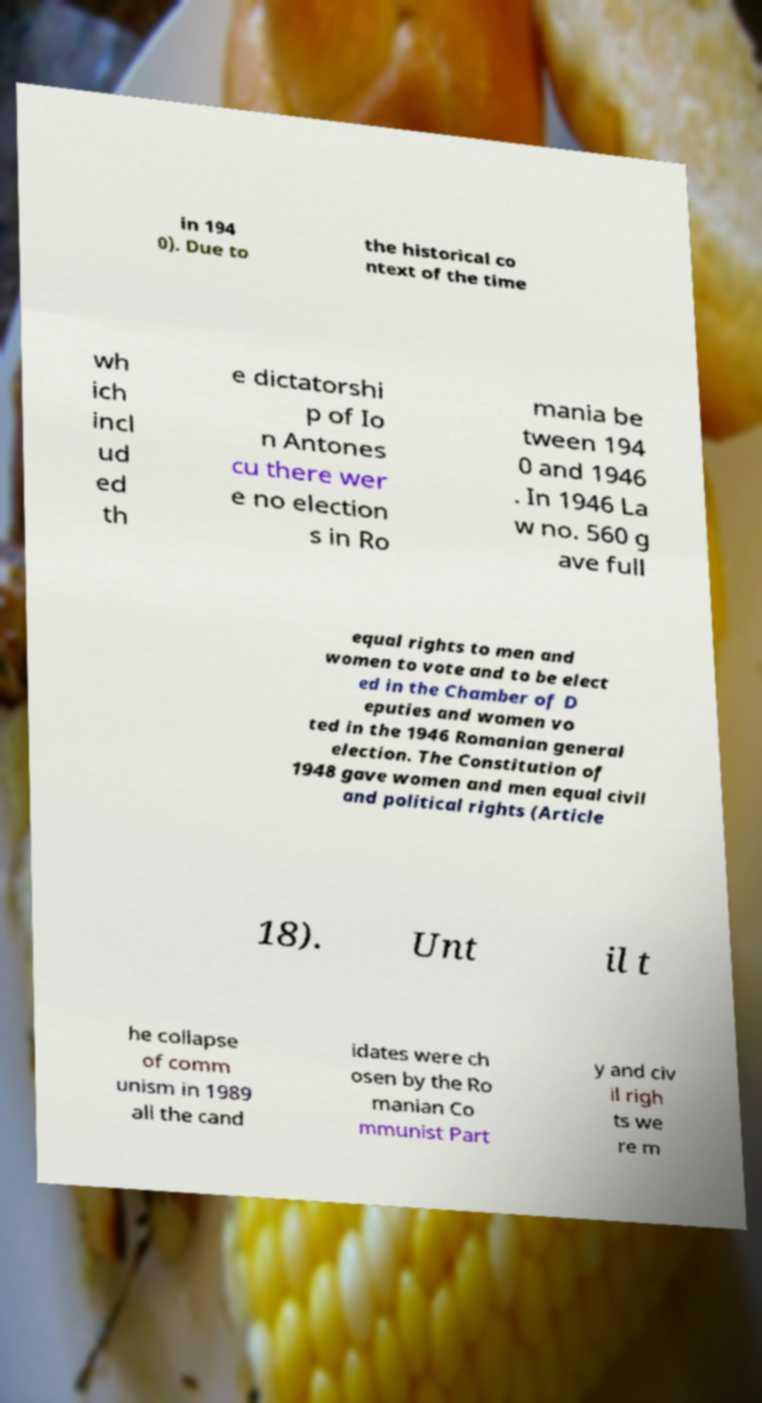Can you read and provide the text displayed in the image?This photo seems to have some interesting text. Can you extract and type it out for me? in 194 0). Due to the historical co ntext of the time wh ich incl ud ed th e dictatorshi p of Io n Antones cu there wer e no election s in Ro mania be tween 194 0 and 1946 . In 1946 La w no. 560 g ave full equal rights to men and women to vote and to be elect ed in the Chamber of D eputies and women vo ted in the 1946 Romanian general election. The Constitution of 1948 gave women and men equal civil and political rights (Article 18). Unt il t he collapse of comm unism in 1989 all the cand idates were ch osen by the Ro manian Co mmunist Part y and civ il righ ts we re m 